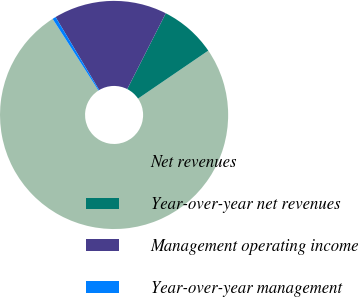Convert chart. <chart><loc_0><loc_0><loc_500><loc_500><pie_chart><fcel>Net revenues<fcel>Year-over-year net revenues<fcel>Management operating income<fcel>Year-over-year management<nl><fcel>75.48%<fcel>7.98%<fcel>16.06%<fcel>0.48%<nl></chart> 